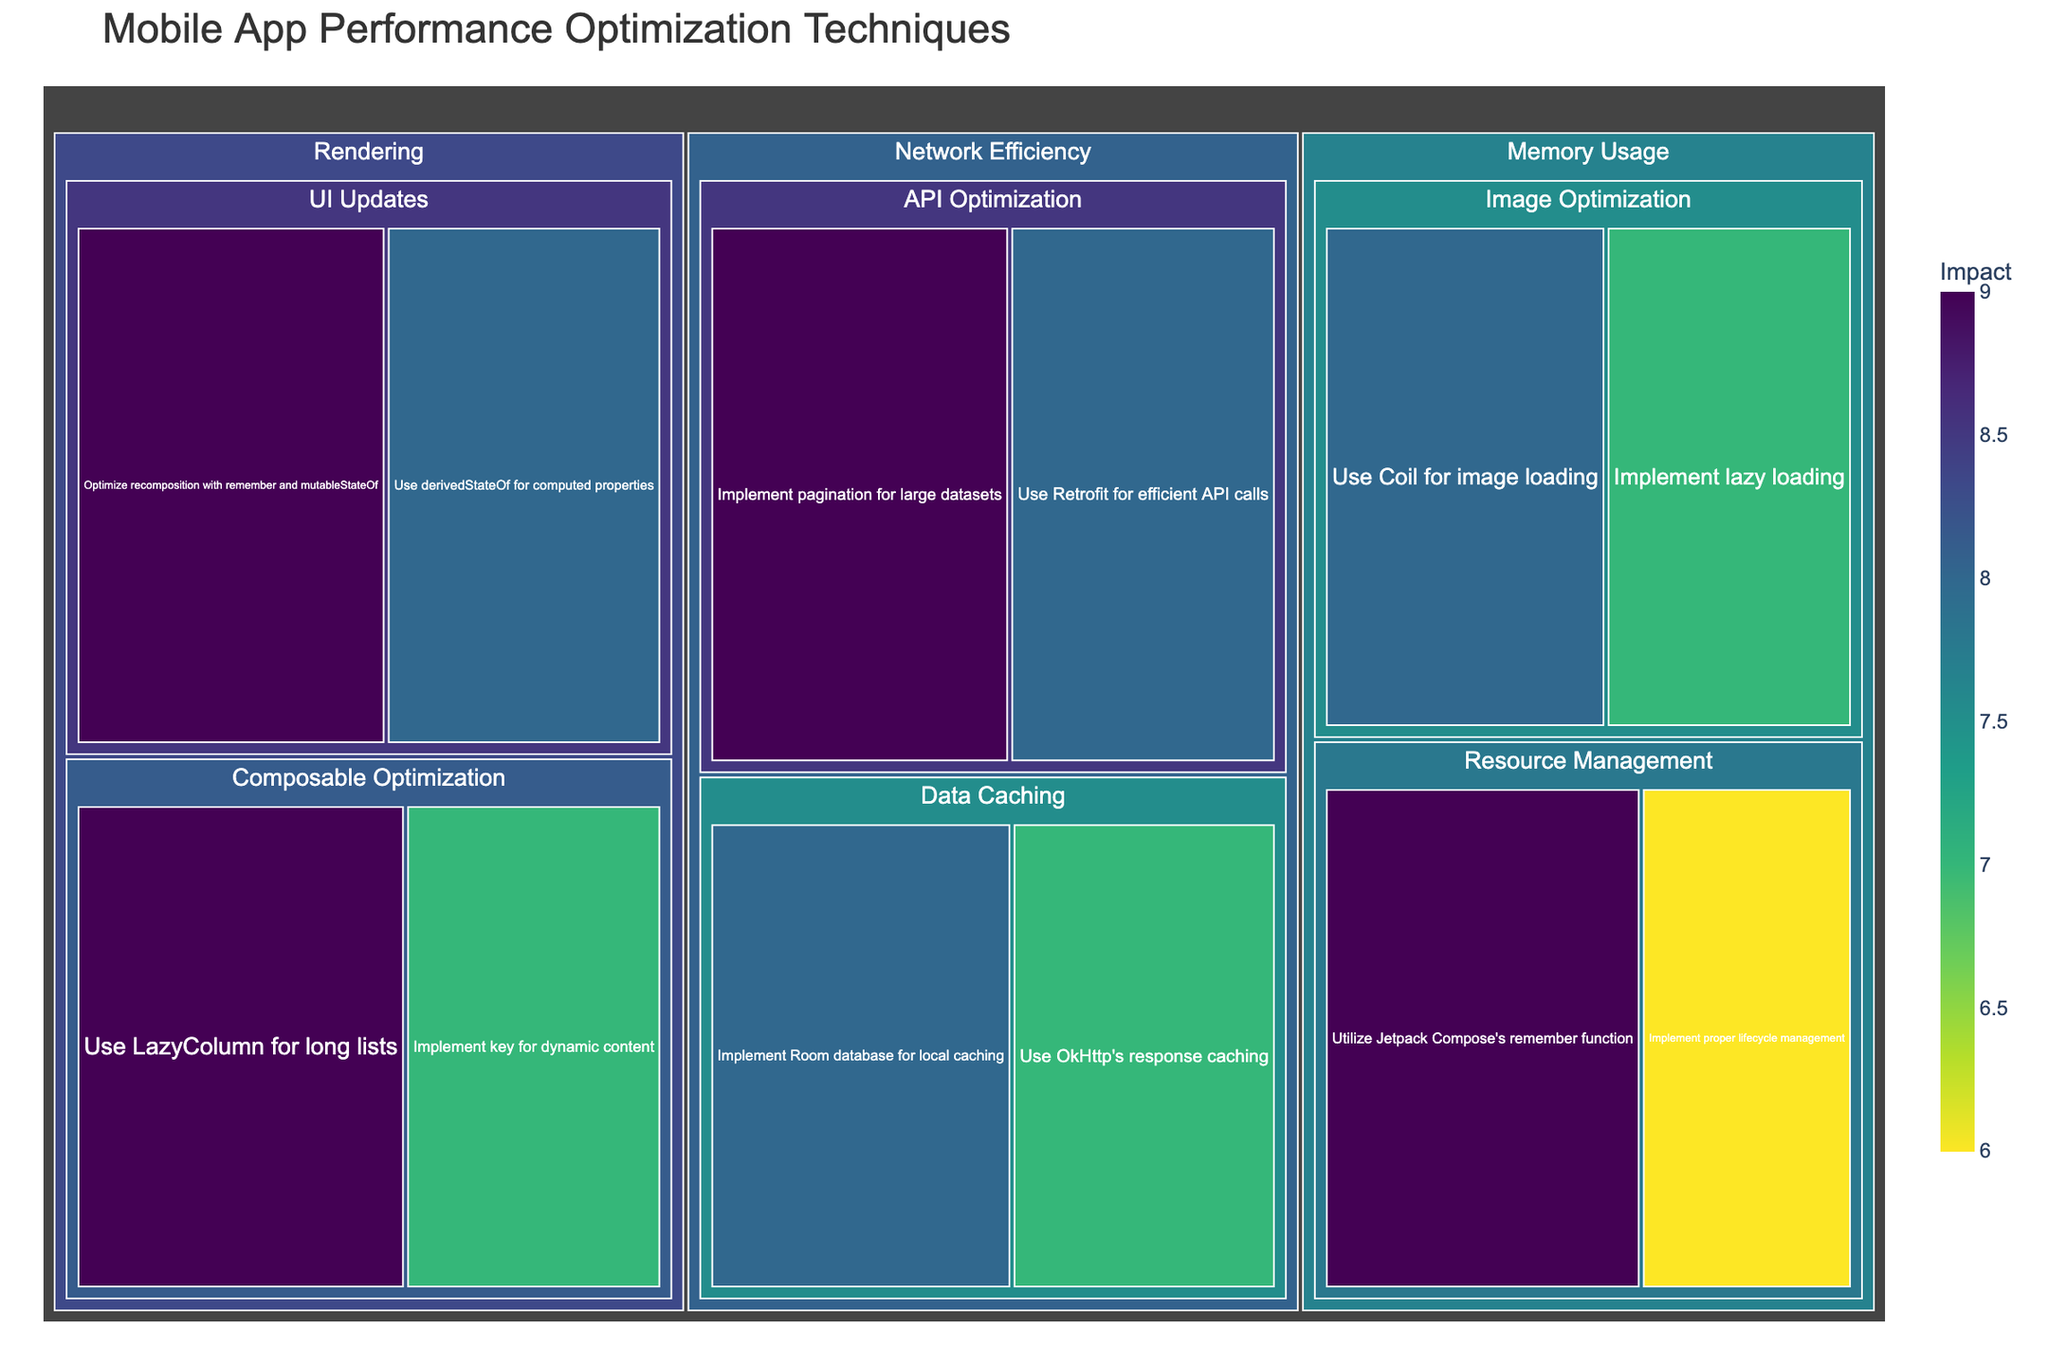What's the title of the treemap? The title is usually prominently displayed at the top of the figure. The figure's title gives an overview of the data being presented.
Answer: Mobile App Performance Optimization Techniques What color represents the highest impact value? Treemaps typically use a continuous color scale to represent the impact value. In this case, the color scale varies from lighter to darker shades, with darker colors usually representing higher values.
Answer: Darker shade Which subcategory under Rendering has the highest impact technique? To answer this, look at the subcategories under Rendering and compare their impact values. Subcategories will have techniques with various impact values indicated by their color and size.
Answer: Composable Optimization How many techniques are listed under Network Efficiency? Count the individual blocks under the Network Efficiency category. Each unique block represents a distinct technique.
Answer: 4 Which category has the most subcategories? Compare the number of subcategories listed under each main category (Memory Usage, Rendering, Network Efficiency). The category with the highest count is the answer.
Answer: Memory Usage What is the total impact score for Image Optimization under Memory Usage? Add the impact values of the techniques listed under the Image Optimization subcategory within Memory Usage. The impact values are 8 and 7. The total is 8 + 7.
Answer: 15 Compare the impact of the most impactful technique in UI Updates to the least impactful technique in API Optimization. Which is greater? Identify the top impact technique under UI Updates and the lowest impact technique under API Optimization. In UI Updates, it's 9. In API Optimization, it's 8. 9 is greater than 8.
Answer: UI Updates has the greater impact What is the average impact of techniques under Data Caching in Network Efficiency? Add the impact values of techniques under Data Caching (8 and 7) and divide by the number of techniques. (8 + 7) / 2 = 7.5
Answer: 7.5 Which single technique has the highest impact in Memory Usage? Under the Memory Usage category, compare the impact values of each technique. The one with the highest value is the answer.
Answer: Utilize Jetpack Compose's remember function Sort the categories in descending order of their highest individual technique impact. What is the order? Identify the highest impact technique in each category: Memory Usage (Utilize Jetpack Compose's remember function: 9), Rendering (Use LazyColumn for long lists: 9), and Network Efficiency (Implement pagination for large datasets: 9). Since all have the same highest individual impact, the order is the same.
Answer: Memory Usage, Rendering, Network Efficiency 